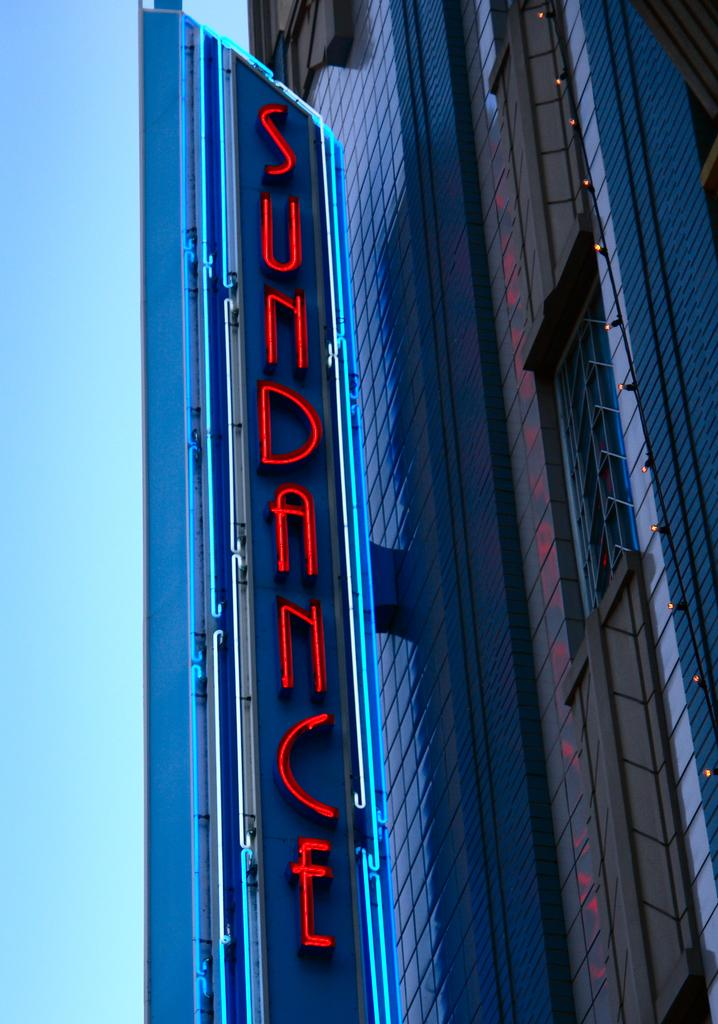What is the main object in the image? There is a board in the image. What type of structure can be seen in the image? There is a glass building in the image. What can be seen in the background of the image? The sky is visible in the background of the image. What type of pump is used to maintain the glass building in the image? There is no pump present in the image, and the glass building does not require a pump for maintenance. 